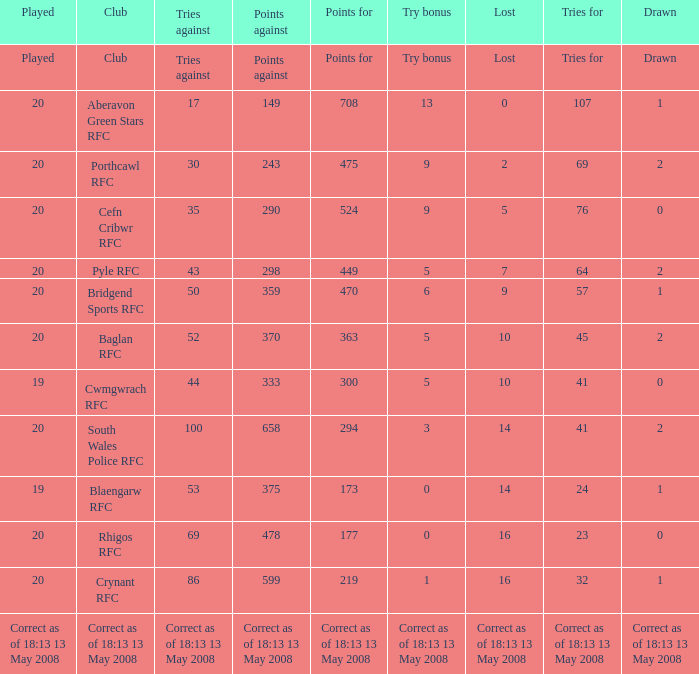What is the tries against when the points are 475? 30.0. Can you give me this table as a dict? {'header': ['Played', 'Club', 'Tries against', 'Points against', 'Points for', 'Try bonus', 'Lost', 'Tries for', 'Drawn'], 'rows': [['Played', 'Club', 'Tries against', 'Points against', 'Points for', 'Try bonus', 'Lost', 'Tries for', 'Drawn'], ['20', 'Aberavon Green Stars RFC', '17', '149', '708', '13', '0', '107', '1'], ['20', 'Porthcawl RFC', '30', '243', '475', '9', '2', '69', '2'], ['20', 'Cefn Cribwr RFC', '35', '290', '524', '9', '5', '76', '0'], ['20', 'Pyle RFC', '43', '298', '449', '5', '7', '64', '2'], ['20', 'Bridgend Sports RFC', '50', '359', '470', '6', '9', '57', '1'], ['20', 'Baglan RFC', '52', '370', '363', '5', '10', '45', '2'], ['19', 'Cwmgwrach RFC', '44', '333', '300', '5', '10', '41', '0'], ['20', 'South Wales Police RFC', '100', '658', '294', '3', '14', '41', '2'], ['19', 'Blaengarw RFC', '53', '375', '173', '0', '14', '24', '1'], ['20', 'Rhigos RFC', '69', '478', '177', '0', '16', '23', '0'], ['20', 'Crynant RFC', '86', '599', '219', '1', '16', '32', '1'], ['Correct as of 18:13 13 May 2008', 'Correct as of 18:13 13 May 2008', 'Correct as of 18:13 13 May 2008', 'Correct as of 18:13 13 May 2008', 'Correct as of 18:13 13 May 2008', 'Correct as of 18:13 13 May 2008', 'Correct as of 18:13 13 May 2008', 'Correct as of 18:13 13 May 2008', 'Correct as of 18:13 13 May 2008']]} 